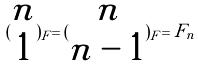<formula> <loc_0><loc_0><loc_500><loc_500>( \begin{matrix} n \\ 1 \end{matrix} ) _ { F } = ( \begin{matrix} n \\ n - 1 \end{matrix} ) _ { F } = F _ { n }</formula> 